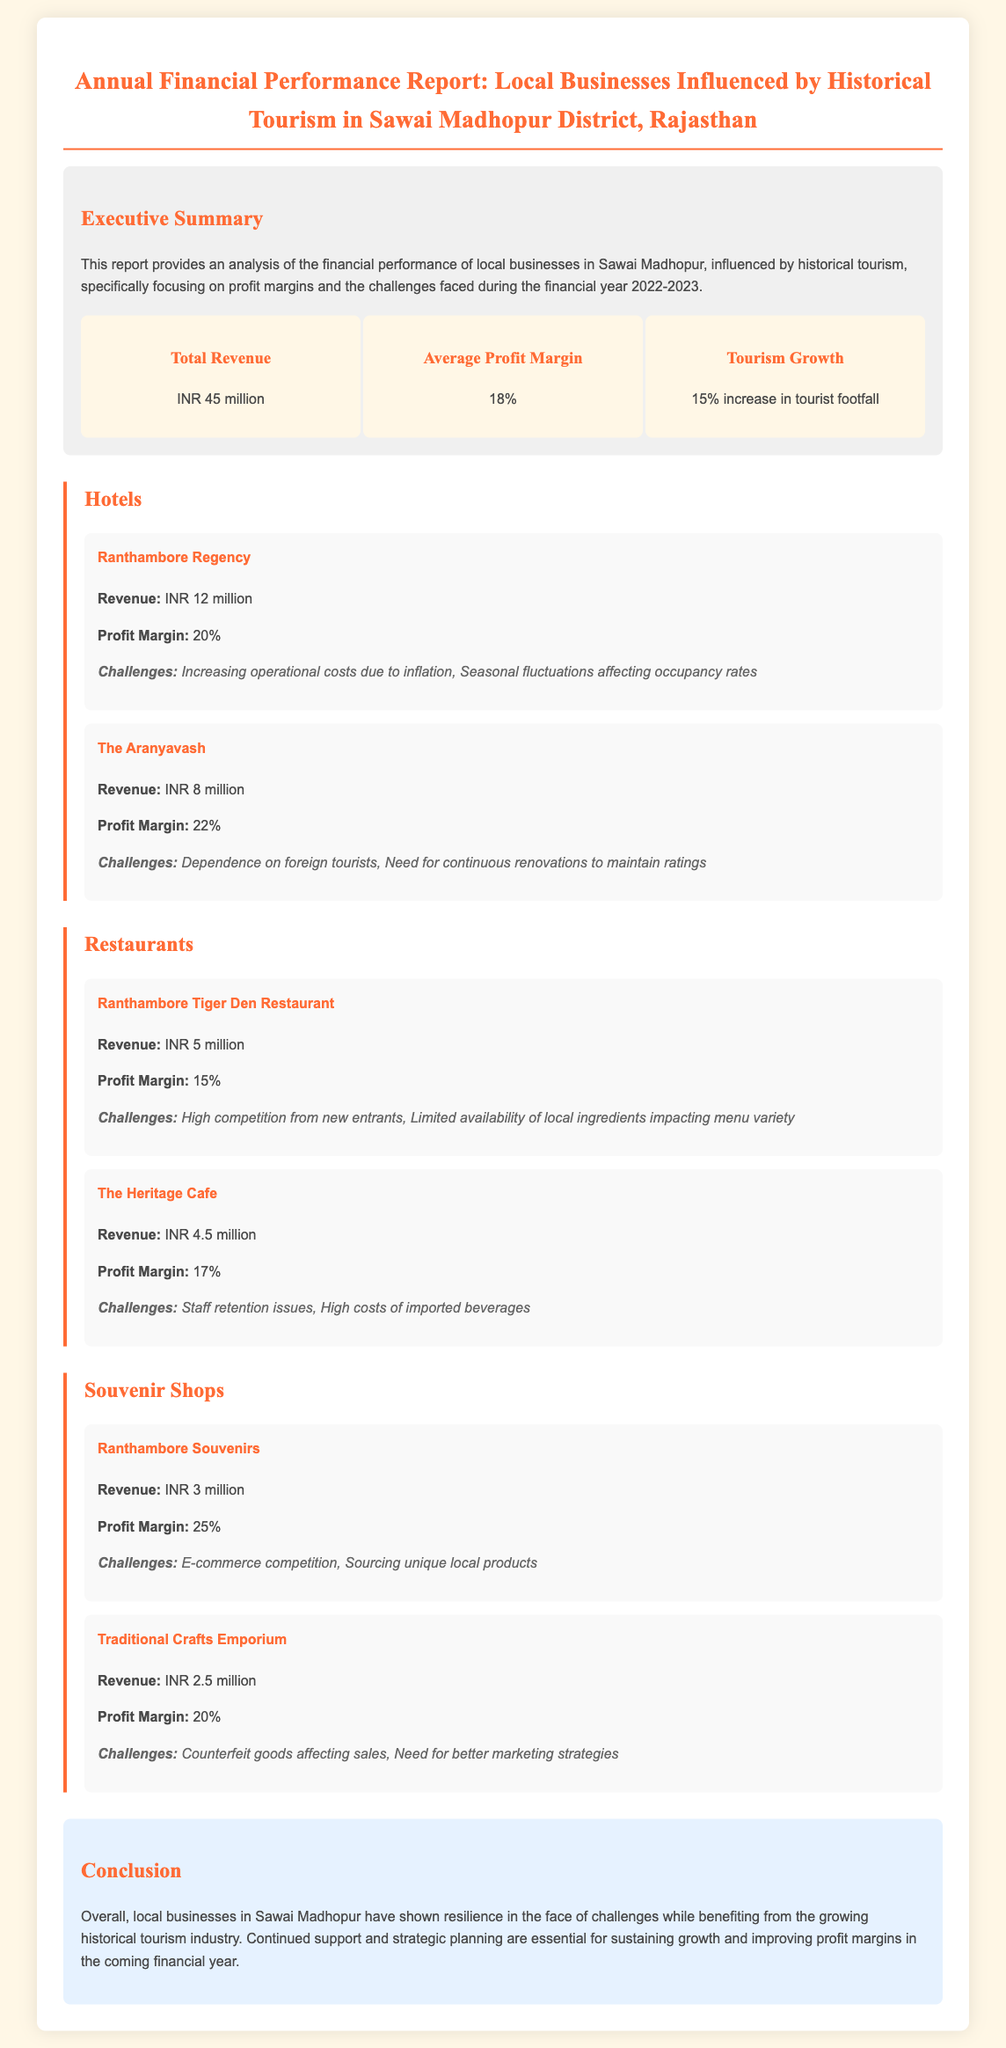what is the total revenue? The total revenue is mentioned in the executive summary as INR 45 million.
Answer: INR 45 million what is the average profit margin? The average profit margin is stated in the executive summary as 18%.
Answer: 18% which hotel has the highest profit margin? By comparing the profit margins of the hotels, The Aranyavash has the highest at 22%.
Answer: The Aranyavash what are the challenges faced by Ranthambore Souvenirs? The challenges for Ranthambore Souvenirs include e-commerce competition and sourcing unique local products.
Answer: E-commerce competition, Sourcing unique local products how much revenue did The Heritage Cafe generate? The revenue for The Heritage Cafe is specified in the document as INR 4.5 million.
Answer: INR 4.5 million what is the profit margin of Ranthambore Tiger Den Restaurant? The profit margin for Ranthambore Tiger Den Restaurant is given as 15%.
Answer: 15% how much did the tourism grow? The document mentions a 15% increase in tourist footfall.
Answer: 15% increase what is a significant challenge for The Aranyavash? A significant challenge mentioned is the dependence on foreign tourists.
Answer: Dependence on foreign tourists what is the total profit margin for souvenir shops? The profit margins for souvenir shops are 25% for Ranthambore Souvenirs and 20% for Traditional Crafts Emporium, but the total is not explicitly given.
Answer: Not explicitly given 